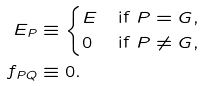Convert formula to latex. <formula><loc_0><loc_0><loc_500><loc_500>E _ { P } & \equiv \begin{cases} E & \text {if $P=G$,} \\ 0 & \text {if $P\neq G$,} \end{cases} \\ f _ { P Q } & \equiv 0 .</formula> 